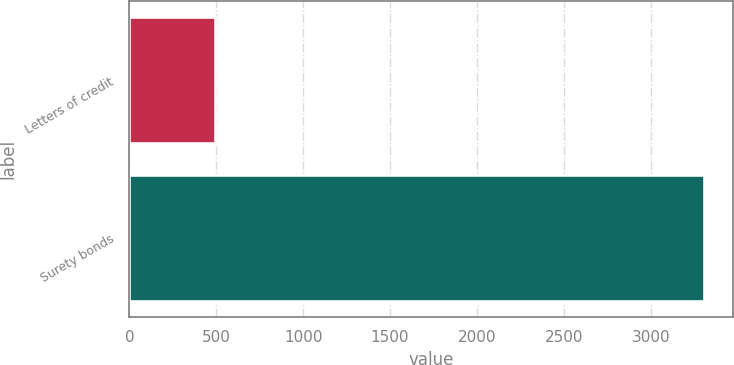Convert chart. <chart><loc_0><loc_0><loc_500><loc_500><bar_chart><fcel>Letters of credit<fcel>Surety bonds<nl><fcel>490.3<fcel>3307.3<nl></chart> 